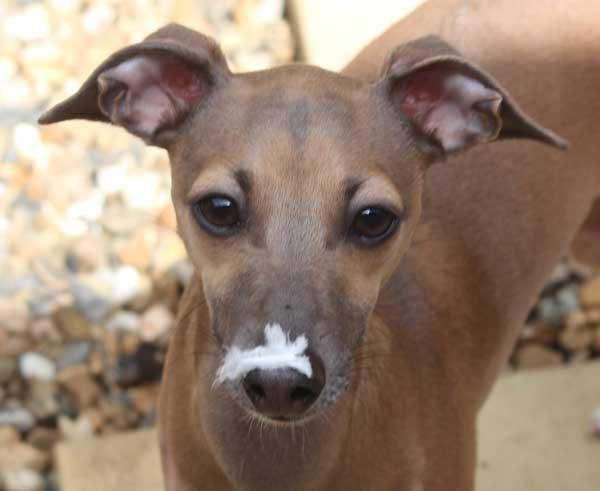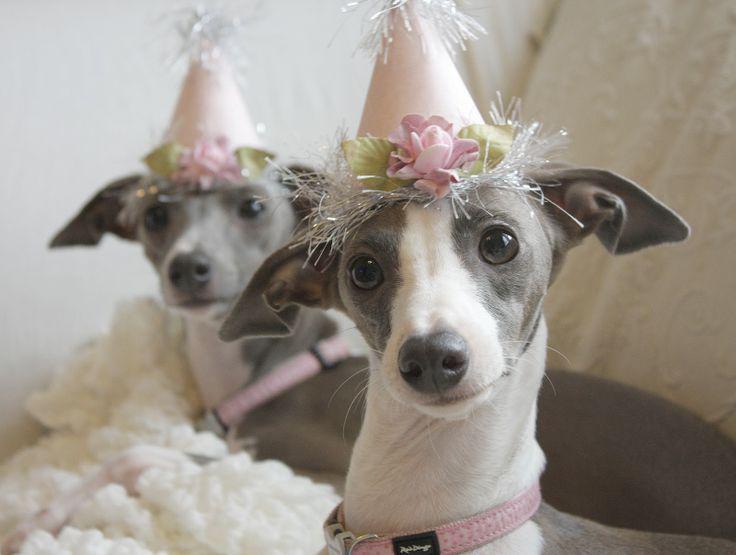The first image is the image on the left, the second image is the image on the right. Considering the images on both sides, is "The combined images include a hound wearing a pink collar and the images include an item of apparel worn by a dog that is not a collar." valid? Answer yes or no. Yes. The first image is the image on the left, the second image is the image on the right. For the images shown, is this caption "There is a collar around the neck of at least one dog in the image on the right." true? Answer yes or no. Yes. 